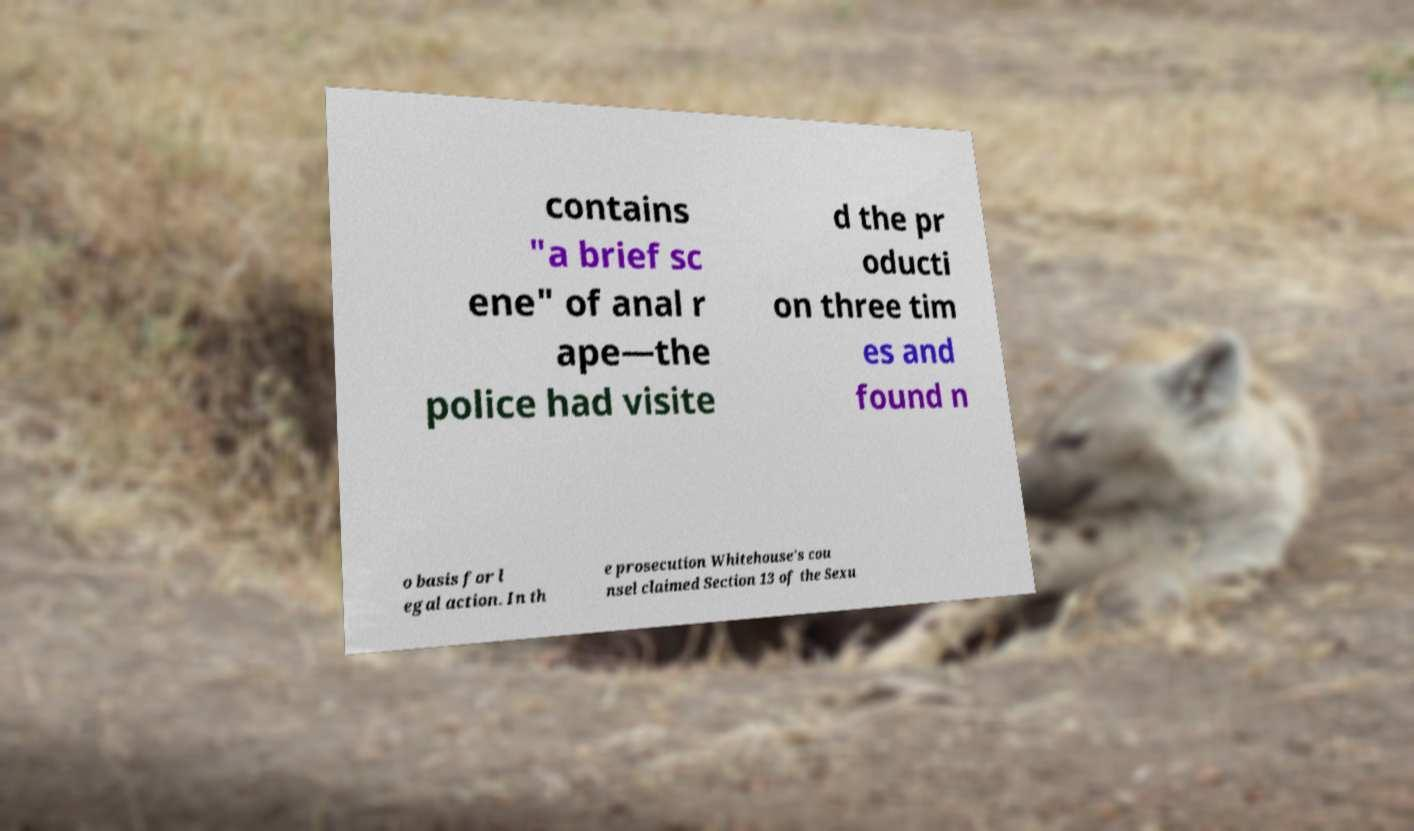Can you read and provide the text displayed in the image?This photo seems to have some interesting text. Can you extract and type it out for me? contains "a brief sc ene" of anal r ape—the police had visite d the pr oducti on three tim es and found n o basis for l egal action. In th e prosecution Whitehouse's cou nsel claimed Section 13 of the Sexu 